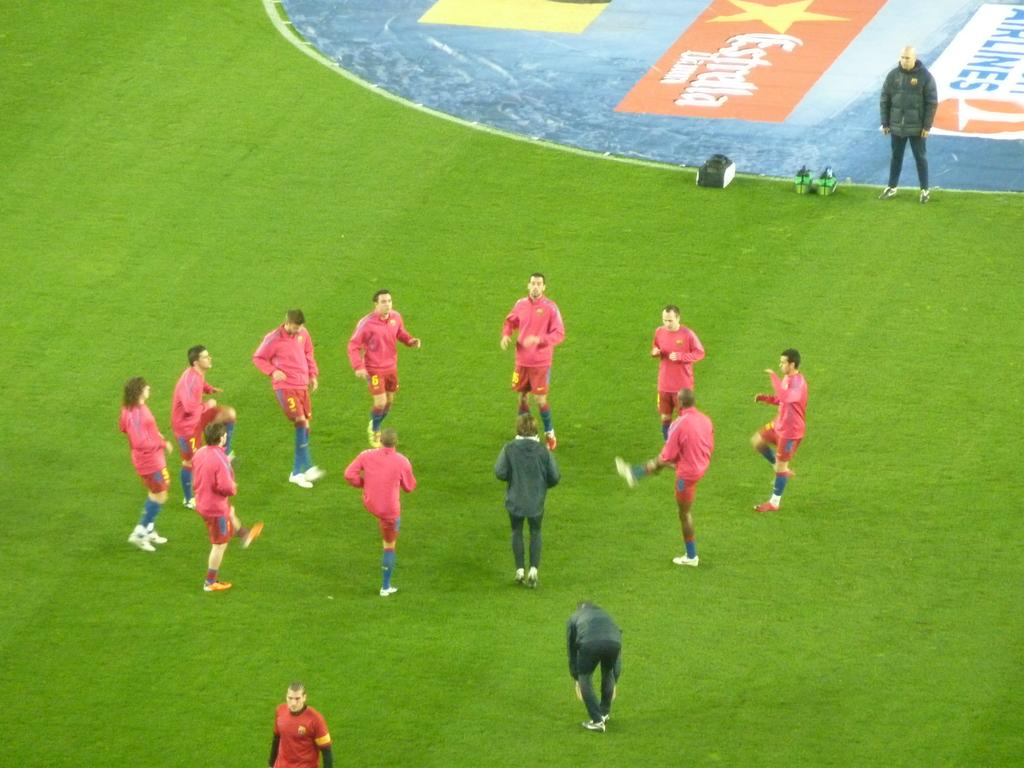<image>
Provide a brief description of the given image. A circle of soccer players near an ad for something Airlines that is painted into the field. 